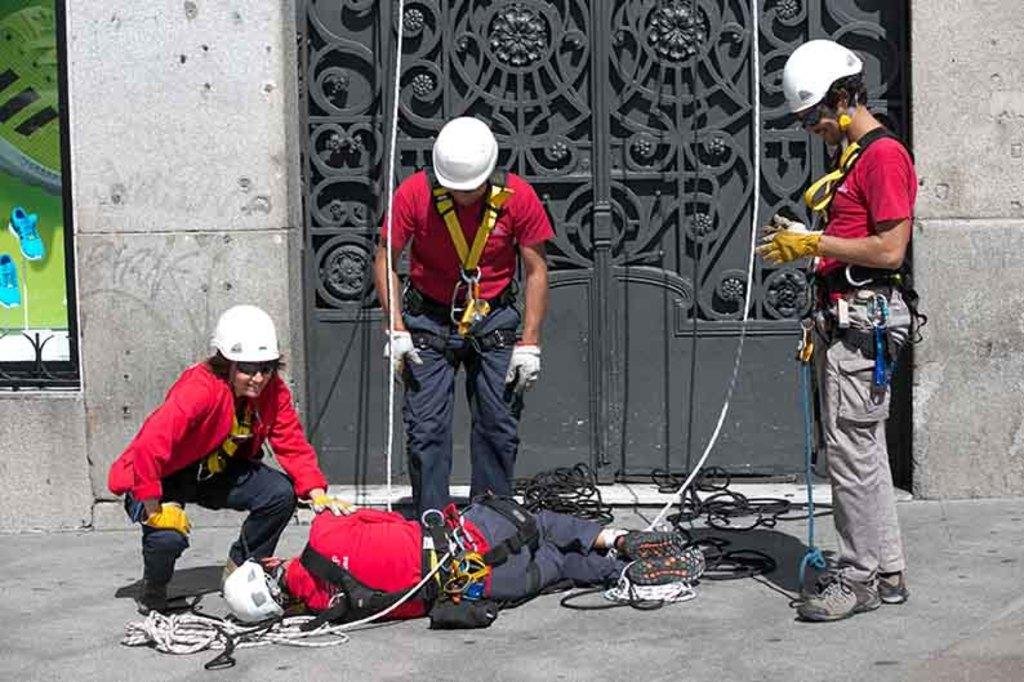What is the position of the person in the image? There is a person lying on the ground in the image. How many other persons are in the image? There are 3 other persons in the image. What are the other persons doing? The other 3 persons are standing and looking at the person lying on the ground. What safety equipment are the standing persons wearing? The standing persons are wearing safety belts and helmets. What type of shoes is the father wearing in the image? There is no mention of a father in the image, nor any information about shoes or feet. 